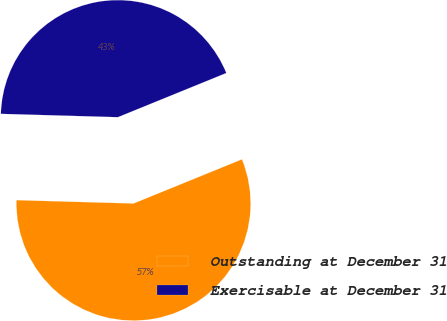Convert chart to OTSL. <chart><loc_0><loc_0><loc_500><loc_500><pie_chart><fcel>Outstanding at December 31<fcel>Exercisable at December 31<nl><fcel>56.61%<fcel>43.39%<nl></chart> 